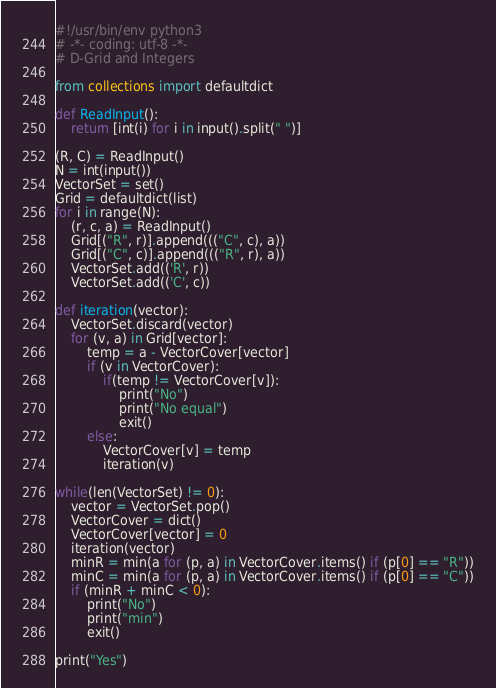Convert code to text. <code><loc_0><loc_0><loc_500><loc_500><_Python_>#!/usr/bin/env python3
# -*- coding: utf-8 -*-
# D-Grid and Integers

from collections import defaultdict

def ReadInput():
	return [int(i) for i in input().split(" ")]

(R, C) = ReadInput()
N = int(input())
VectorSet = set() 
Grid = defaultdict(list)
for i in range(N):
	(r, c, a) = ReadInput()
	Grid[("R", r)].append((("C", c), a))
	Grid[("C", c)].append((("R", r), a))
	VectorSet.add(('R', r))
	VectorSet.add(('C', c))

def iteration(vector):
	VectorSet.discard(vector)
	for (v, a) in Grid[vector]:
		temp = a - VectorCover[vector]
		if (v in VectorCover):
			if(temp != VectorCover[v]):
				print("No")
				print("No equal")
				exit()
		else:
			VectorCover[v] = temp
			iteration(v) 

while(len(VectorSet) != 0):
	vector = VectorSet.pop()
	VectorCover = dict() 
	VectorCover[vector] = 0
	iteration(vector)
	minR = min(a for (p, a) in VectorCover.items() if (p[0] == "R"))
	minC = min(a for (p, a) in VectorCover.items() if (p[0] == "C"))
	if (minR + minC < 0):
		print("No")
		print("min")
		exit()
		
print("Yes")
</code> 